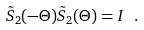Convert formula to latex. <formula><loc_0><loc_0><loc_500><loc_500>\tilde { S } _ { 2 } ( - \Theta ) \tilde { S } _ { 2 } ( \Theta ) = I \ .</formula> 